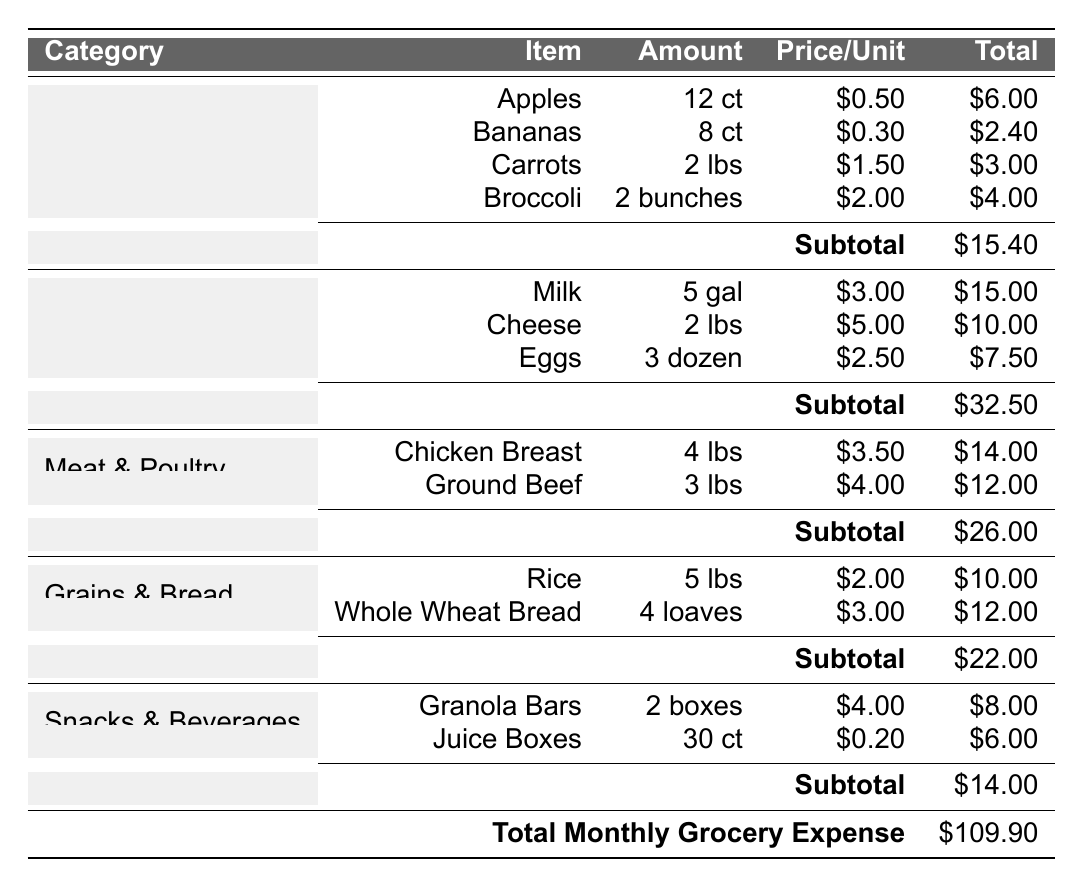What is the total expense for Dairy & Eggs? The total expense for the Dairy & Eggs category is listed at the bottom of that section as \$32.50.
Answer: \$32.50 Which item has the highest individual price per unit? The item with the highest price per unit is Cheese, costing \$5.00 per lb.
Answer: Cheese What is the overall total monthly grocery expense? The overall total monthly grocery expense is reflected at the bottom of the table as \$109.90.
Answer: \$109.90 How much did you spend on Fruits & Vegetables compared to Snacks & Beverages? The expense for Fruits & Vegetables is \$15.40, and for Snacks & Beverages, it is \$14.00. To compare, \( 15.40 - 14.00 = 1.40 \). Therefore, you spent \$1.40 more on Fruits & Vegetables.
Answer: \$1.40 more What is the total expense for Grains & Bread? The total expense listed in the Grains & Bread section is \$22.00.
Answer: \$22.00 How many total units of Snacks & Beverages were purchased? The total units for Snacks & Beverages can be calculated by adding the unit counts for Granola Bars (2 boxes) and Juice Boxes (30 count), giving a total of \( 2 + 30 = 32 \) units.
Answer: 32 Which category had the lowest total expense? The category with the lowest total expense is Snacks & Beverages, with \$14.00.
Answer: Snacks & Beverages What is the average amount spent on each category? To find the average, sum all category totals: \( 15.40 + 32.50 + 26.00 + 22.00 + 14.00 = 109.90 \). Then divide by the number of categories (5), giving \( 109.90 / 5 = 21.98 \).
Answer: \$21.98 Is the total for Meat & Poultry more than the total for Dairy & Eggs? The total for Meat & Poultry is \$26.00, while Dairy & Eggs total \$32.50. Since \( 26.00 < 32.50 \), the statement is false.
Answer: No How much more was spent on Meat & Poultry than on Fruits & Vegetables? The expenses are \$26.00 for Meat & Poultry and \$15.40 for Fruits & Vegetables. The difference is \( 26.00 - 15.40 = 10.60 \), indicating \$10.60 more was spent on Meat & Poultry.
Answer: \$10.60 more 